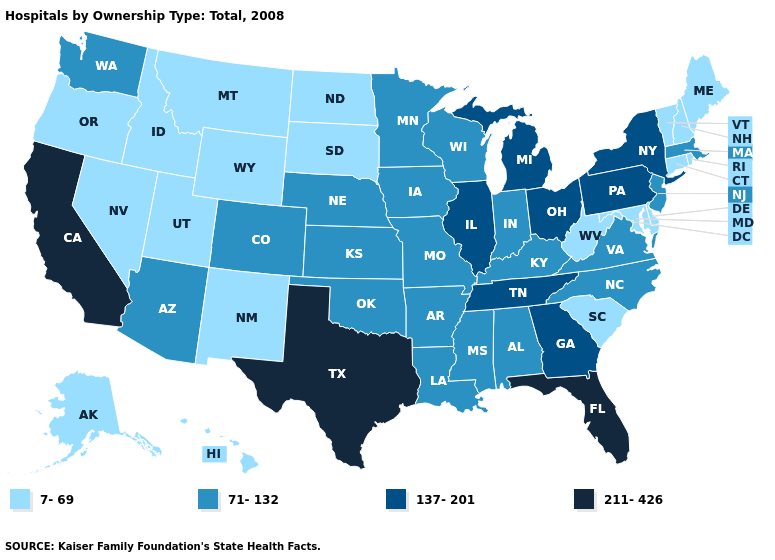Does Oklahoma have the lowest value in the USA?
Concise answer only. No. Which states have the lowest value in the USA?
Give a very brief answer. Alaska, Connecticut, Delaware, Hawaii, Idaho, Maine, Maryland, Montana, Nevada, New Hampshire, New Mexico, North Dakota, Oregon, Rhode Island, South Carolina, South Dakota, Utah, Vermont, West Virginia, Wyoming. Does Georgia have the same value as Texas?
Answer briefly. No. Name the states that have a value in the range 71-132?
Short answer required. Alabama, Arizona, Arkansas, Colorado, Indiana, Iowa, Kansas, Kentucky, Louisiana, Massachusetts, Minnesota, Mississippi, Missouri, Nebraska, New Jersey, North Carolina, Oklahoma, Virginia, Washington, Wisconsin. How many symbols are there in the legend?
Keep it brief. 4. Name the states that have a value in the range 137-201?
Concise answer only. Georgia, Illinois, Michigan, New York, Ohio, Pennsylvania, Tennessee. Among the states that border California , which have the highest value?
Keep it brief. Arizona. Does West Virginia have the same value as Rhode Island?
Answer briefly. Yes. What is the value of South Carolina?
Short answer required. 7-69. Which states hav the highest value in the West?
Write a very short answer. California. What is the value of Nevada?
Write a very short answer. 7-69. Among the states that border Vermont , does New York have the lowest value?
Answer briefly. No. Name the states that have a value in the range 7-69?
Quick response, please. Alaska, Connecticut, Delaware, Hawaii, Idaho, Maine, Maryland, Montana, Nevada, New Hampshire, New Mexico, North Dakota, Oregon, Rhode Island, South Carolina, South Dakota, Utah, Vermont, West Virginia, Wyoming. Among the states that border New Jersey , which have the highest value?
Give a very brief answer. New York, Pennsylvania. Which states have the highest value in the USA?
Concise answer only. California, Florida, Texas. 